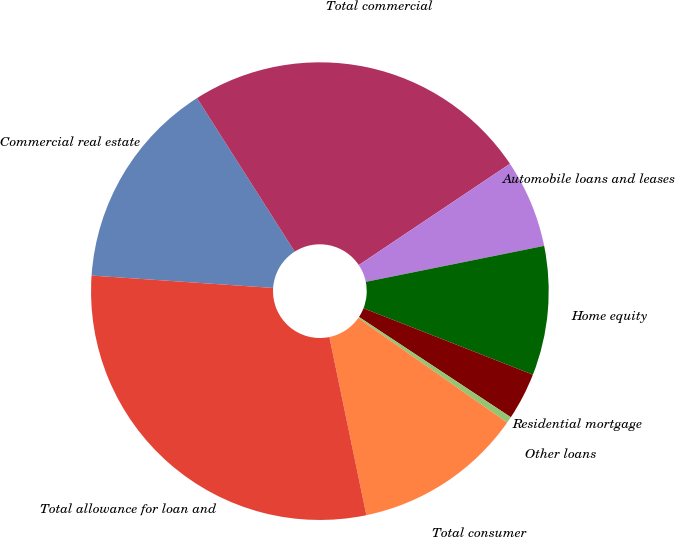Convert chart. <chart><loc_0><loc_0><loc_500><loc_500><pie_chart><fcel>Commercial real estate<fcel>Total commercial<fcel>Automobile loans and leases<fcel>Home equity<fcel>Residential mortgage<fcel>Other loans<fcel>Total consumer<fcel>Total allowance for loan and<nl><fcel>14.9%<fcel>24.63%<fcel>6.23%<fcel>9.12%<fcel>3.34%<fcel>0.45%<fcel>12.01%<fcel>29.35%<nl></chart> 